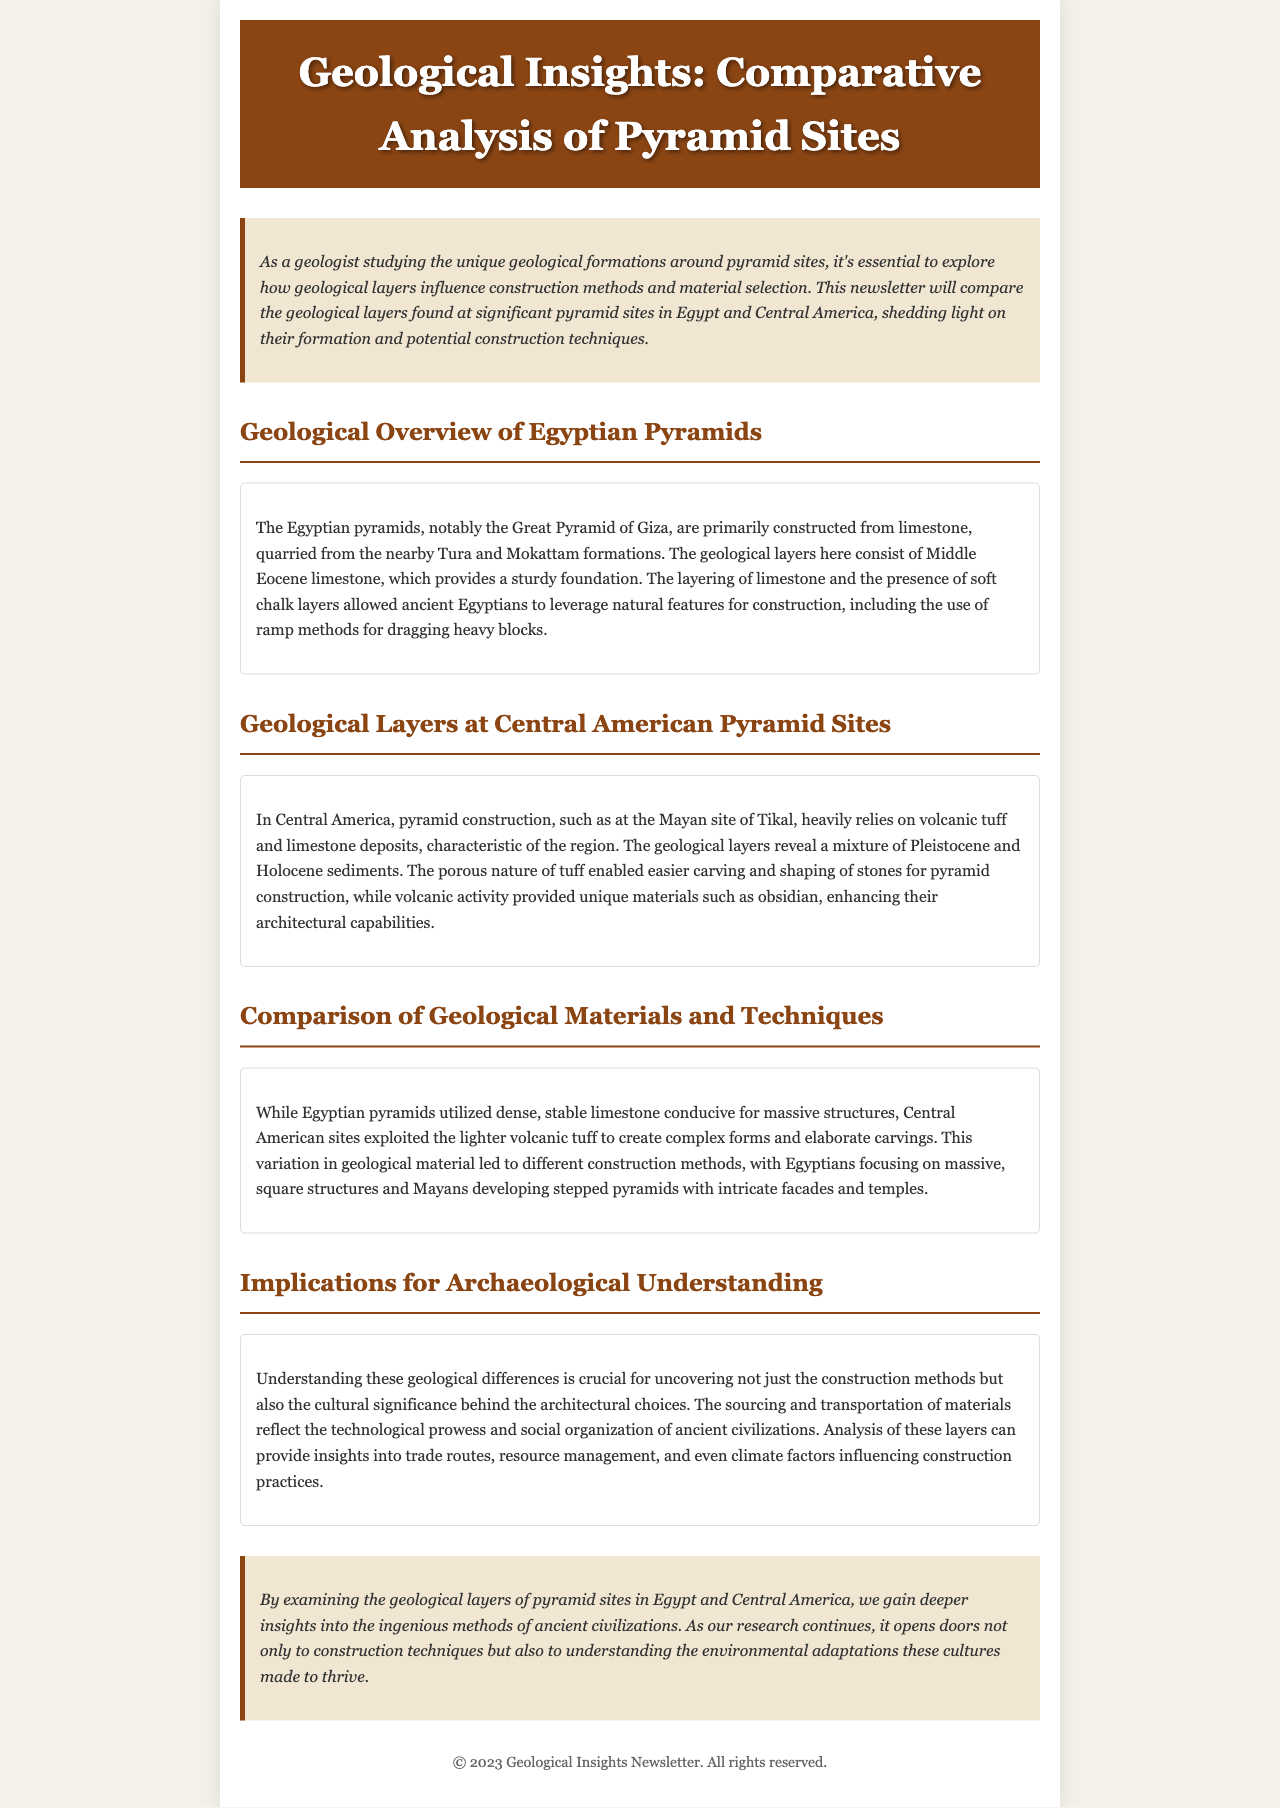What type of limestone is used in Egyptian pyramids? The document specifies that the Egyptian pyramids are primarily constructed from Middle Eocene limestone.
Answer: Middle Eocene limestone What material is heavily relied on for pyramid construction in Central America? The newsletter states that Central American pyramids rely on volcanic tuff and limestone deposits.
Answer: Volcanic tuff and limestone What construction method did ancient Egyptians leverage for heavy blocks? The document mentions that ancient Egyptians used ramp methods for dragging heavy blocks.
Answer: Ramp methods Which pyramid site is mentioned as a notable example from Central America? The document references the Mayan site of Tikal as a significant pyramid site in Central America.
Answer: Tikal What geological period do the sediments at Central American pyramid sites belong to? The document indicates that the geological layers at Central American pyramid sites consist of Pleistocene and Holocene sediments.
Answer: Pleistocene and Holocene What is a key difference in pyramid design between Egyptians and Mayans? The newsletter notes that Egyptians focused on massive, square structures while Mayans developed stepped pyramids.
Answer: Stepped pyramids What does understanding geological differences help uncover? The document suggests that understanding these geological differences can uncover construction methods and cultural significance.
Answer: Construction methods and cultural significance How do the pyramids' geological materials affect architectural capabilities? The document explains that the porous nature of tuff enabled easier carving and shaping of stones for pyramid construction in Central America.
Answer: Easier carving and shaping What is one implication of analyzing the geological layers mentioned in the document? The newsletter states that analysis of these layers can provide insights into trade routes and resource management.
Answer: Trade routes and resource management 